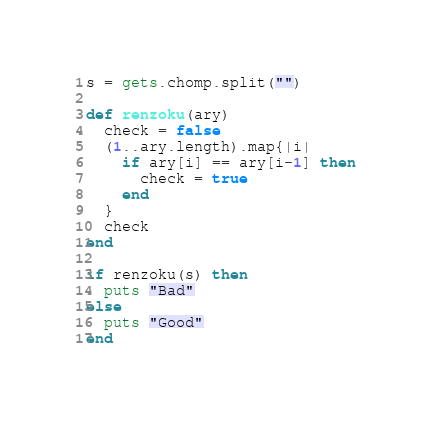<code> <loc_0><loc_0><loc_500><loc_500><_Ruby_>s = gets.chomp.split("")

def renzoku(ary)
  check = false
  (1..ary.length).map{|i|
    if ary[i] == ary[i-1] then
      check = true
    end
  }
  check
end

if renzoku(s) then
  puts "Bad"
else
  puts "Good"
end
</code> 